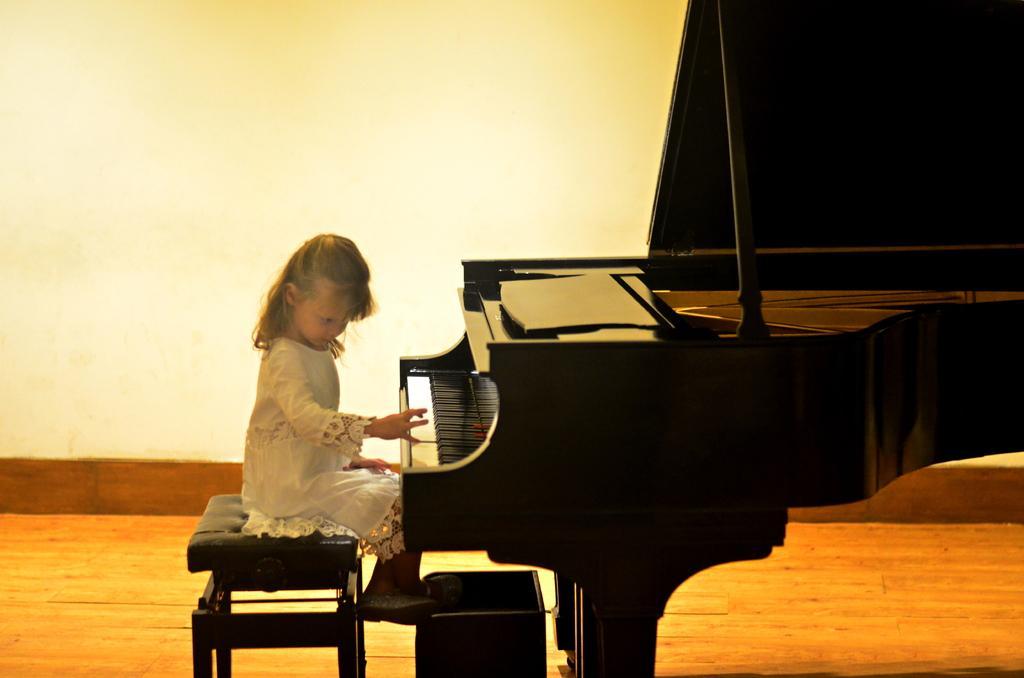Please provide a concise description of this image. This girl sitting on the chair and playing piano. On the background we can see wall. This is floor. 